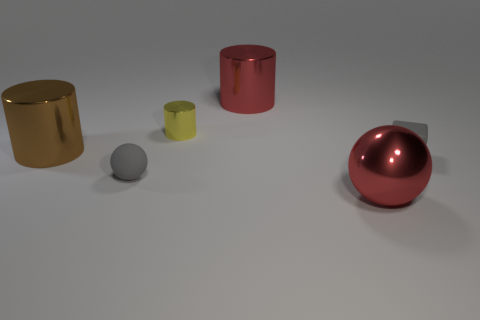Add 2 yellow shiny objects. How many objects exist? 8 Subtract all cubes. How many objects are left? 5 Subtract all small gray balls. Subtract all big brown objects. How many objects are left? 4 Add 3 metallic things. How many metallic things are left? 7 Add 3 gray spheres. How many gray spheres exist? 4 Subtract 0 purple blocks. How many objects are left? 6 